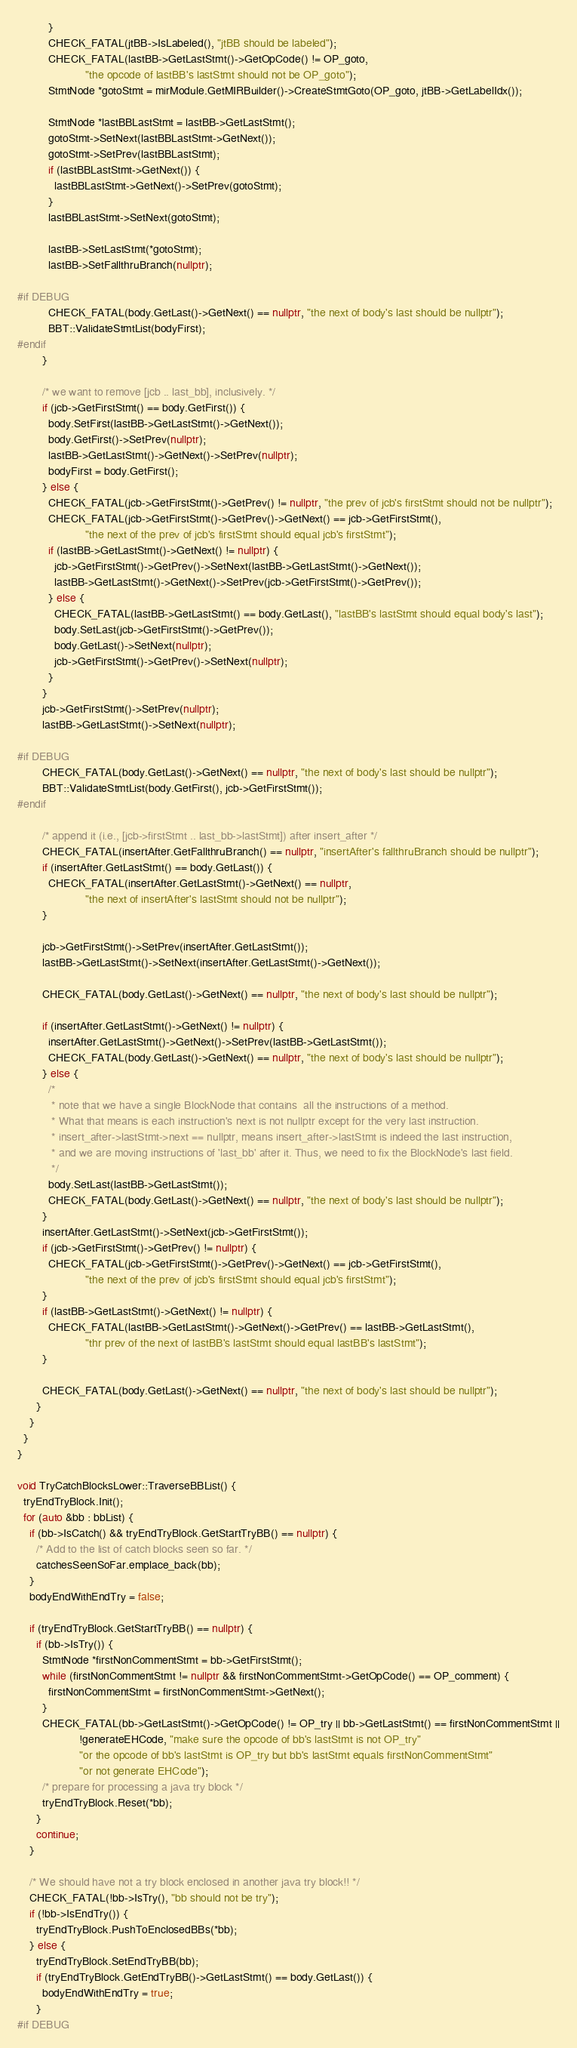Convert code to text. <code><loc_0><loc_0><loc_500><loc_500><_C++_>          }
          CHECK_FATAL(jtBB->IsLabeled(), "jtBB should be labeled");
          CHECK_FATAL(lastBB->GetLastStmt()->GetOpCode() != OP_goto,
                      "the opcode of lastBB's lastStmt should not be OP_goto");
          StmtNode *gotoStmt = mirModule.GetMIRBuilder()->CreateStmtGoto(OP_goto, jtBB->GetLabelIdx());

          StmtNode *lastBBLastStmt = lastBB->GetLastStmt();
          gotoStmt->SetNext(lastBBLastStmt->GetNext());
          gotoStmt->SetPrev(lastBBLastStmt);
          if (lastBBLastStmt->GetNext()) {
            lastBBLastStmt->GetNext()->SetPrev(gotoStmt);
          }
          lastBBLastStmt->SetNext(gotoStmt);

          lastBB->SetLastStmt(*gotoStmt);
          lastBB->SetFallthruBranch(nullptr);

#if DEBUG
          CHECK_FATAL(body.GetLast()->GetNext() == nullptr, "the next of body's last should be nullptr");
          BBT::ValidateStmtList(bodyFirst);
#endif
        }

        /* we want to remove [jcb .. last_bb], inclusively. */
        if (jcb->GetFirstStmt() == body.GetFirst()) {
          body.SetFirst(lastBB->GetLastStmt()->GetNext());
          body.GetFirst()->SetPrev(nullptr);
          lastBB->GetLastStmt()->GetNext()->SetPrev(nullptr);
          bodyFirst = body.GetFirst();
        } else {
          CHECK_FATAL(jcb->GetFirstStmt()->GetPrev() != nullptr, "the prev of jcb's firstStmt should not be nullptr");
          CHECK_FATAL(jcb->GetFirstStmt()->GetPrev()->GetNext() == jcb->GetFirstStmt(),
                      "the next of the prev of jcb's firstStmt should equal jcb's firstStmt");
          if (lastBB->GetLastStmt()->GetNext() != nullptr) {
            jcb->GetFirstStmt()->GetPrev()->SetNext(lastBB->GetLastStmt()->GetNext());
            lastBB->GetLastStmt()->GetNext()->SetPrev(jcb->GetFirstStmt()->GetPrev());
          } else {
            CHECK_FATAL(lastBB->GetLastStmt() == body.GetLast(), "lastBB's lastStmt should equal body's last");
            body.SetLast(jcb->GetFirstStmt()->GetPrev());
            body.GetLast()->SetNext(nullptr);
            jcb->GetFirstStmt()->GetPrev()->SetNext(nullptr);
          }
        }
        jcb->GetFirstStmt()->SetPrev(nullptr);
        lastBB->GetLastStmt()->SetNext(nullptr);

#if DEBUG
        CHECK_FATAL(body.GetLast()->GetNext() == nullptr, "the next of body's last should be nullptr");
        BBT::ValidateStmtList(body.GetFirst(), jcb->GetFirstStmt());
#endif

        /* append it (i.e., [jcb->firstStmt .. last_bb->lastStmt]) after insert_after */
        CHECK_FATAL(insertAfter.GetFallthruBranch() == nullptr, "insertAfter's fallthruBranch should be nullptr");
        if (insertAfter.GetLastStmt() == body.GetLast()) {
          CHECK_FATAL(insertAfter.GetLastStmt()->GetNext() == nullptr,
                      "the next of insertAfter's lastStmt should not be nullptr");
        }

        jcb->GetFirstStmt()->SetPrev(insertAfter.GetLastStmt());
        lastBB->GetLastStmt()->SetNext(insertAfter.GetLastStmt()->GetNext());

        CHECK_FATAL(body.GetLast()->GetNext() == nullptr, "the next of body's last should be nullptr");

        if (insertAfter.GetLastStmt()->GetNext() != nullptr) {
          insertAfter.GetLastStmt()->GetNext()->SetPrev(lastBB->GetLastStmt());
          CHECK_FATAL(body.GetLast()->GetNext() == nullptr, "the next of body's last should be nullptr");
        } else {
          /*
           * note that we have a single BlockNode that contains  all the instructions of a method.
           * What that means is each instruction's next is not nullptr except for the very last instruction.
           * insert_after->lastStmt->next == nullptr, means insert_after->lastStmt is indeed the last instruction,
           * and we are moving instructions of 'last_bb' after it. Thus, we need to fix the BlockNode's last field.
           */
          body.SetLast(lastBB->GetLastStmt());
          CHECK_FATAL(body.GetLast()->GetNext() == nullptr, "the next of body's last should be nullptr");
        }
        insertAfter.GetLastStmt()->SetNext(jcb->GetFirstStmt());
        if (jcb->GetFirstStmt()->GetPrev() != nullptr) {
          CHECK_FATAL(jcb->GetFirstStmt()->GetPrev()->GetNext() == jcb->GetFirstStmt(),
                      "the next of the prev of jcb's firstStmt should equal jcb's firstStmt");
        }
        if (lastBB->GetLastStmt()->GetNext() != nullptr) {
          CHECK_FATAL(lastBB->GetLastStmt()->GetNext()->GetPrev() == lastBB->GetLastStmt(),
                      "thr prev of the next of lastBB's lastStmt should equal lastBB's lastStmt");
        }

        CHECK_FATAL(body.GetLast()->GetNext() == nullptr, "the next of body's last should be nullptr");
      }
    }
  }
}

void TryCatchBlocksLower::TraverseBBList() {
  tryEndTryBlock.Init();
  for (auto &bb : bbList) {
    if (bb->IsCatch() && tryEndTryBlock.GetStartTryBB() == nullptr) {
      /* Add to the list of catch blocks seen so far. */
      catchesSeenSoFar.emplace_back(bb);
    }
    bodyEndWithEndTry = false;

    if (tryEndTryBlock.GetStartTryBB() == nullptr) {
      if (bb->IsTry()) {
        StmtNode *firstNonCommentStmt = bb->GetFirstStmt();
        while (firstNonCommentStmt != nullptr && firstNonCommentStmt->GetOpCode() == OP_comment) {
          firstNonCommentStmt = firstNonCommentStmt->GetNext();
        }
        CHECK_FATAL(bb->GetLastStmt()->GetOpCode() != OP_try || bb->GetLastStmt() == firstNonCommentStmt ||
                    !generateEHCode, "make sure the opcode of bb's lastStmt is not OP_try"
                    "or the opcode of bb's lastStmt is OP_try but bb's lastStmt equals firstNonCommentStmt"
                    "or not generate EHCode");
        /* prepare for processing a java try block */
        tryEndTryBlock.Reset(*bb);
      }
      continue;
    }

    /* We should have not a try block enclosed in another java try block!! */
    CHECK_FATAL(!bb->IsTry(), "bb should not be try");
    if (!bb->IsEndTry()) {
      tryEndTryBlock.PushToEnclosedBBs(*bb);
    } else {
      tryEndTryBlock.SetEndTryBB(bb);
      if (tryEndTryBlock.GetEndTryBB()->GetLastStmt() == body.GetLast()) {
        bodyEndWithEndTry = true;
      }
#if DEBUG</code> 